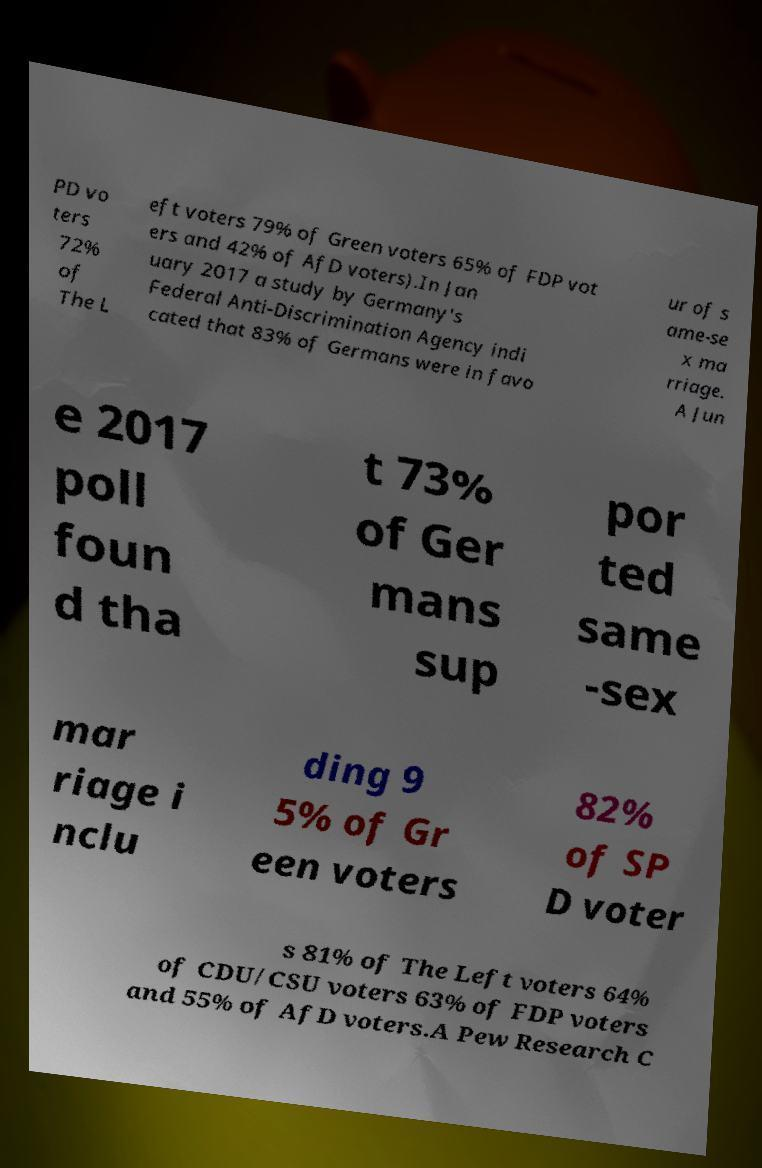Can you accurately transcribe the text from the provided image for me? PD vo ters 72% of The L eft voters 79% of Green voters 65% of FDP vot ers and 42% of AfD voters).In Jan uary 2017 a study by Germany's Federal Anti-Discrimination Agency indi cated that 83% of Germans were in favo ur of s ame-se x ma rriage. A Jun e 2017 poll foun d tha t 73% of Ger mans sup por ted same -sex mar riage i nclu ding 9 5% of Gr een voters 82% of SP D voter s 81% of The Left voters 64% of CDU/CSU voters 63% of FDP voters and 55% of AfD voters.A Pew Research C 